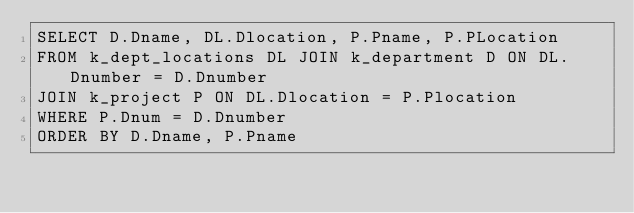Convert code to text. <code><loc_0><loc_0><loc_500><loc_500><_SQL_>SELECT D.Dname, DL.Dlocation, P.Pname, P.PLocation
FROM k_dept_locations DL JOIN k_department D ON DL.Dnumber = D.Dnumber
JOIN k_project P ON DL.Dlocation = P.Plocation
WHERE P.Dnum = D.Dnumber
ORDER BY D.Dname, P.Pname</code> 